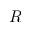Convert formula to latex. <formula><loc_0><loc_0><loc_500><loc_500>R</formula> 